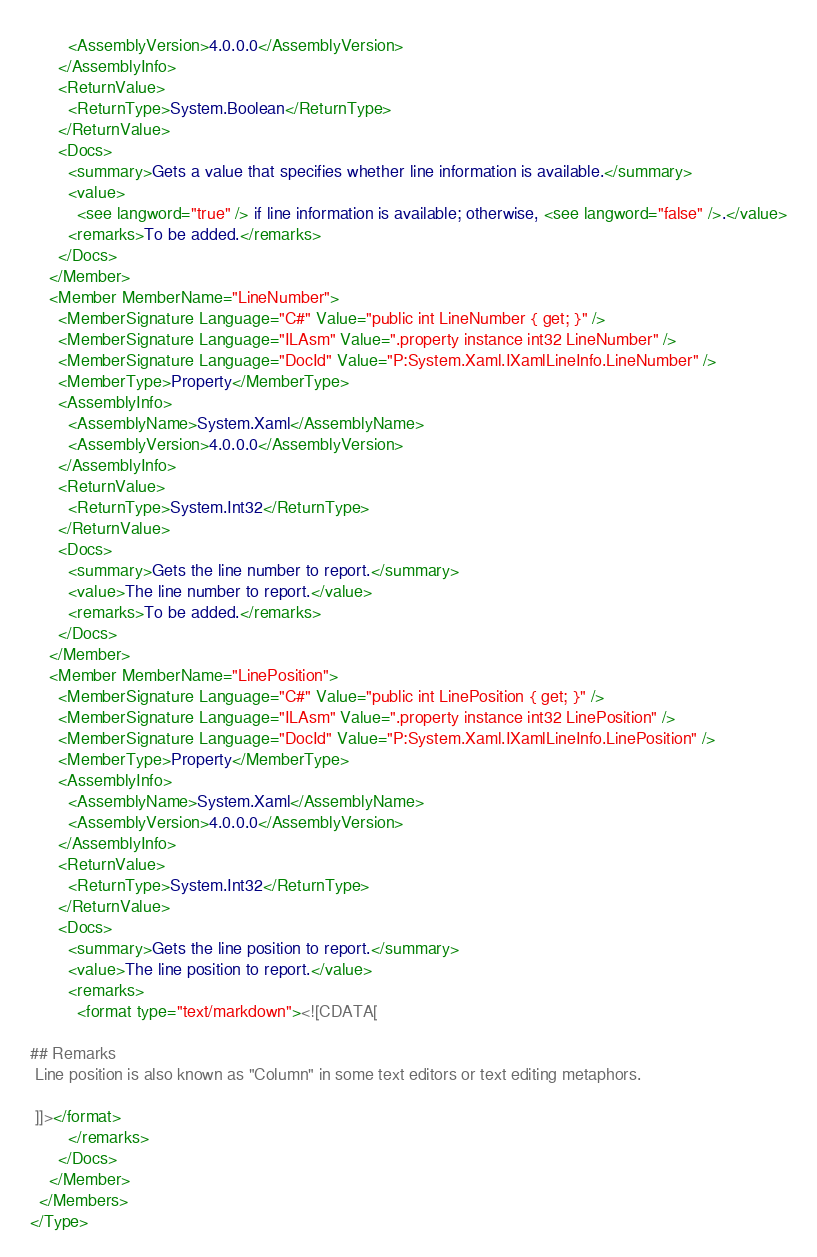Convert code to text. <code><loc_0><loc_0><loc_500><loc_500><_XML_>        <AssemblyVersion>4.0.0.0</AssemblyVersion>
      </AssemblyInfo>
      <ReturnValue>
        <ReturnType>System.Boolean</ReturnType>
      </ReturnValue>
      <Docs>
        <summary>Gets a value that specifies whether line information is available.</summary>
        <value>
          <see langword="true" /> if line information is available; otherwise, <see langword="false" />.</value>
        <remarks>To be added.</remarks>
      </Docs>
    </Member>
    <Member MemberName="LineNumber">
      <MemberSignature Language="C#" Value="public int LineNumber { get; }" />
      <MemberSignature Language="ILAsm" Value=".property instance int32 LineNumber" />
      <MemberSignature Language="DocId" Value="P:System.Xaml.IXamlLineInfo.LineNumber" />
      <MemberType>Property</MemberType>
      <AssemblyInfo>
        <AssemblyName>System.Xaml</AssemblyName>
        <AssemblyVersion>4.0.0.0</AssemblyVersion>
      </AssemblyInfo>
      <ReturnValue>
        <ReturnType>System.Int32</ReturnType>
      </ReturnValue>
      <Docs>
        <summary>Gets the line number to report.</summary>
        <value>The line number to report.</value>
        <remarks>To be added.</remarks>
      </Docs>
    </Member>
    <Member MemberName="LinePosition">
      <MemberSignature Language="C#" Value="public int LinePosition { get; }" />
      <MemberSignature Language="ILAsm" Value=".property instance int32 LinePosition" />
      <MemberSignature Language="DocId" Value="P:System.Xaml.IXamlLineInfo.LinePosition" />
      <MemberType>Property</MemberType>
      <AssemblyInfo>
        <AssemblyName>System.Xaml</AssemblyName>
        <AssemblyVersion>4.0.0.0</AssemblyVersion>
      </AssemblyInfo>
      <ReturnValue>
        <ReturnType>System.Int32</ReturnType>
      </ReturnValue>
      <Docs>
        <summary>Gets the line position to report.</summary>
        <value>The line position to report.</value>
        <remarks>
          <format type="text/markdown"><![CDATA[  
  
## Remarks  
 Line position is also known as "Column" in some text editors or text editing metaphors.  
  
 ]]></format>
        </remarks>
      </Docs>
    </Member>
  </Members>
</Type>
</code> 